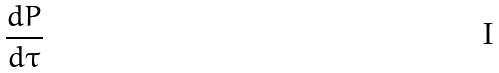Convert formula to latex. <formula><loc_0><loc_0><loc_500><loc_500>\frac { d P } { d \tau }</formula> 